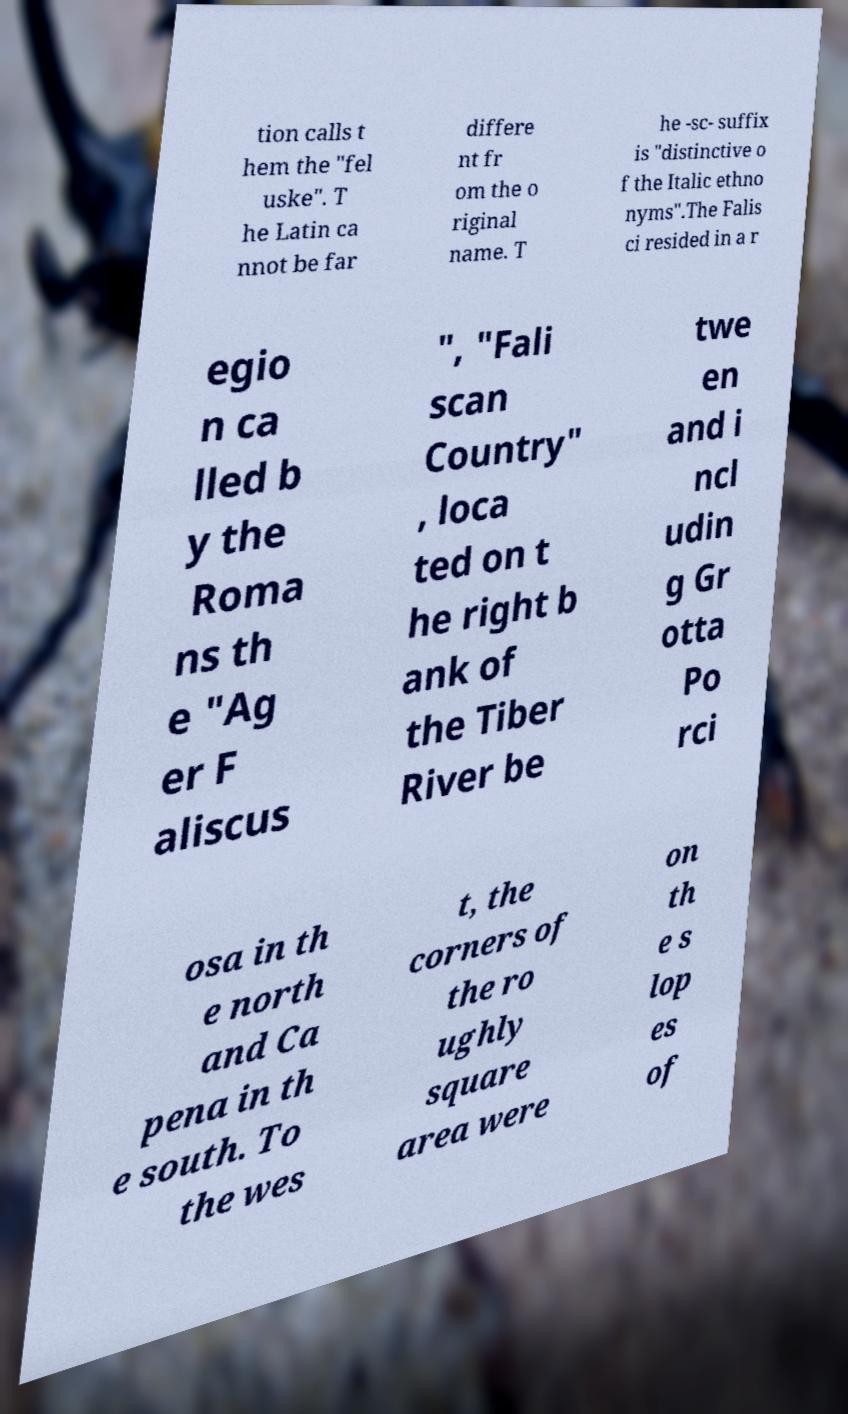Could you assist in decoding the text presented in this image and type it out clearly? tion calls t hem the "fel uske". T he Latin ca nnot be far differe nt fr om the o riginal name. T he -sc- suffix is "distinctive o f the Italic ethno nyms".The Falis ci resided in a r egio n ca lled b y the Roma ns th e "Ag er F aliscus ", "Fali scan Country" , loca ted on t he right b ank of the Tiber River be twe en and i ncl udin g Gr otta Po rci osa in th e north and Ca pena in th e south. To the wes t, the corners of the ro ughly square area were on th e s lop es of 